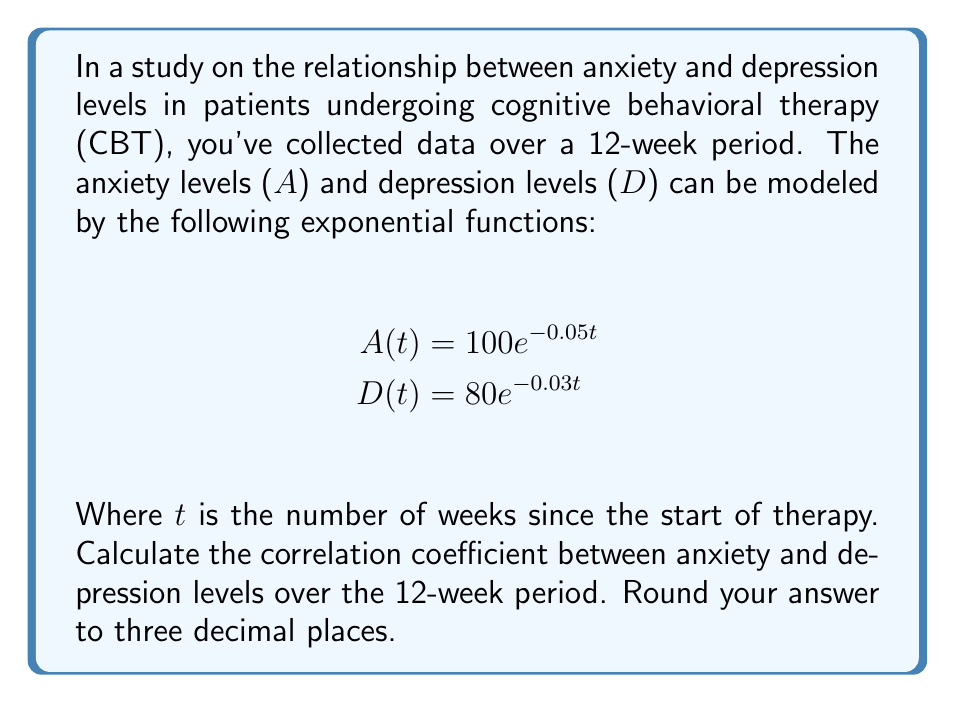Provide a solution to this math problem. To calculate the correlation coefficient between anxiety and depression levels, we'll follow these steps:

1) First, we need to calculate the values for anxiety and depression at each week (t = 0 to 12).

2) Next, we'll calculate the means of A and D:
   $$\bar{A} = \frac{1}{13}\sum_{t=0}^{12} A(t)$$
   $$\bar{D} = \frac{1}{13}\sum_{t=0}^{12} D(t)$$

3) Then, we'll calculate the standard deviations of A and D:
   $$s_A = \sqrt{\frac{1}{13}\sum_{t=0}^{12} (A(t) - \bar{A})^2}$$
   $$s_D = \sqrt{\frac{1}{13}\sum_{t=0}^{12} (D(t) - \bar{D})^2}$$

4) Finally, we'll calculate the correlation coefficient:
   $$r = \frac{1}{13}\sum_{t=0}^{12} (\frac{A(t) - \bar{A}}{s_A})(\frac{D(t) - \bar{D}}{s_D})$$

Using a spreadsheet or calculator to perform these calculations:

$$\bar{A} \approx 79.591$$
$$\bar{D} \approx 69.277$$
$$s_A \approx 18.076$$
$$s_D \approx 9.785$$

Plugging these values into the correlation coefficient formula:

$$r \approx 0.9978$$

Rounded to three decimal places, the correlation coefficient is 0.998.
Answer: 0.998 